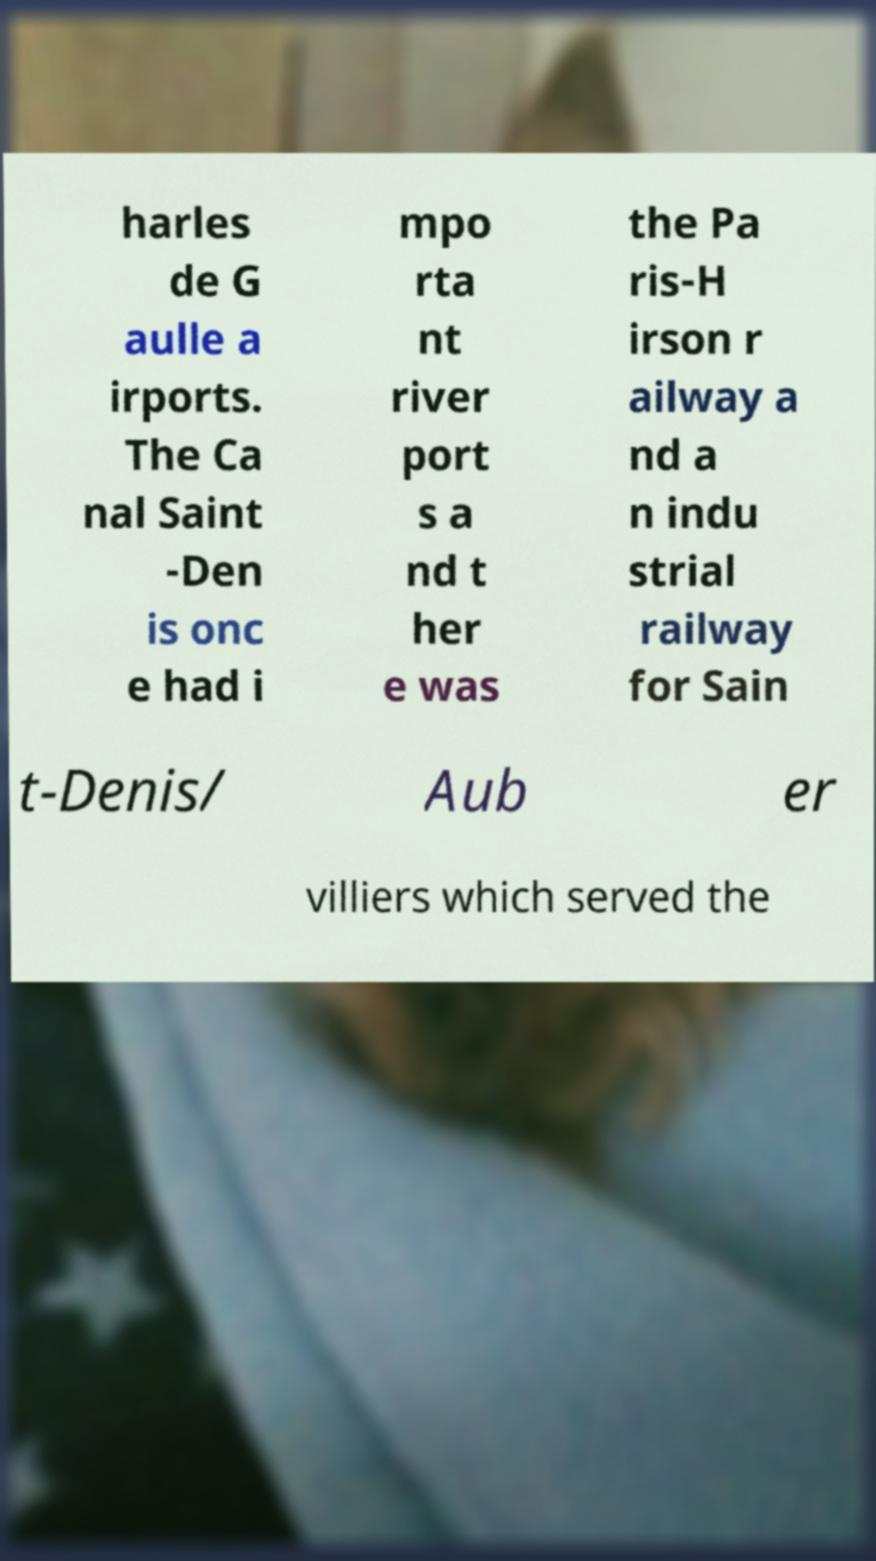Could you extract and type out the text from this image? harles de G aulle a irports. The Ca nal Saint -Den is onc e had i mpo rta nt river port s a nd t her e was the Pa ris-H irson r ailway a nd a n indu strial railway for Sain t-Denis/ Aub er villiers which served the 